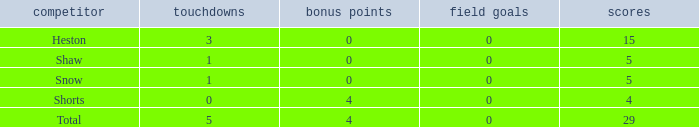What is the total number of field goals a player had when there were more than 0 extra points and there were 5 touchdowns? 1.0. 